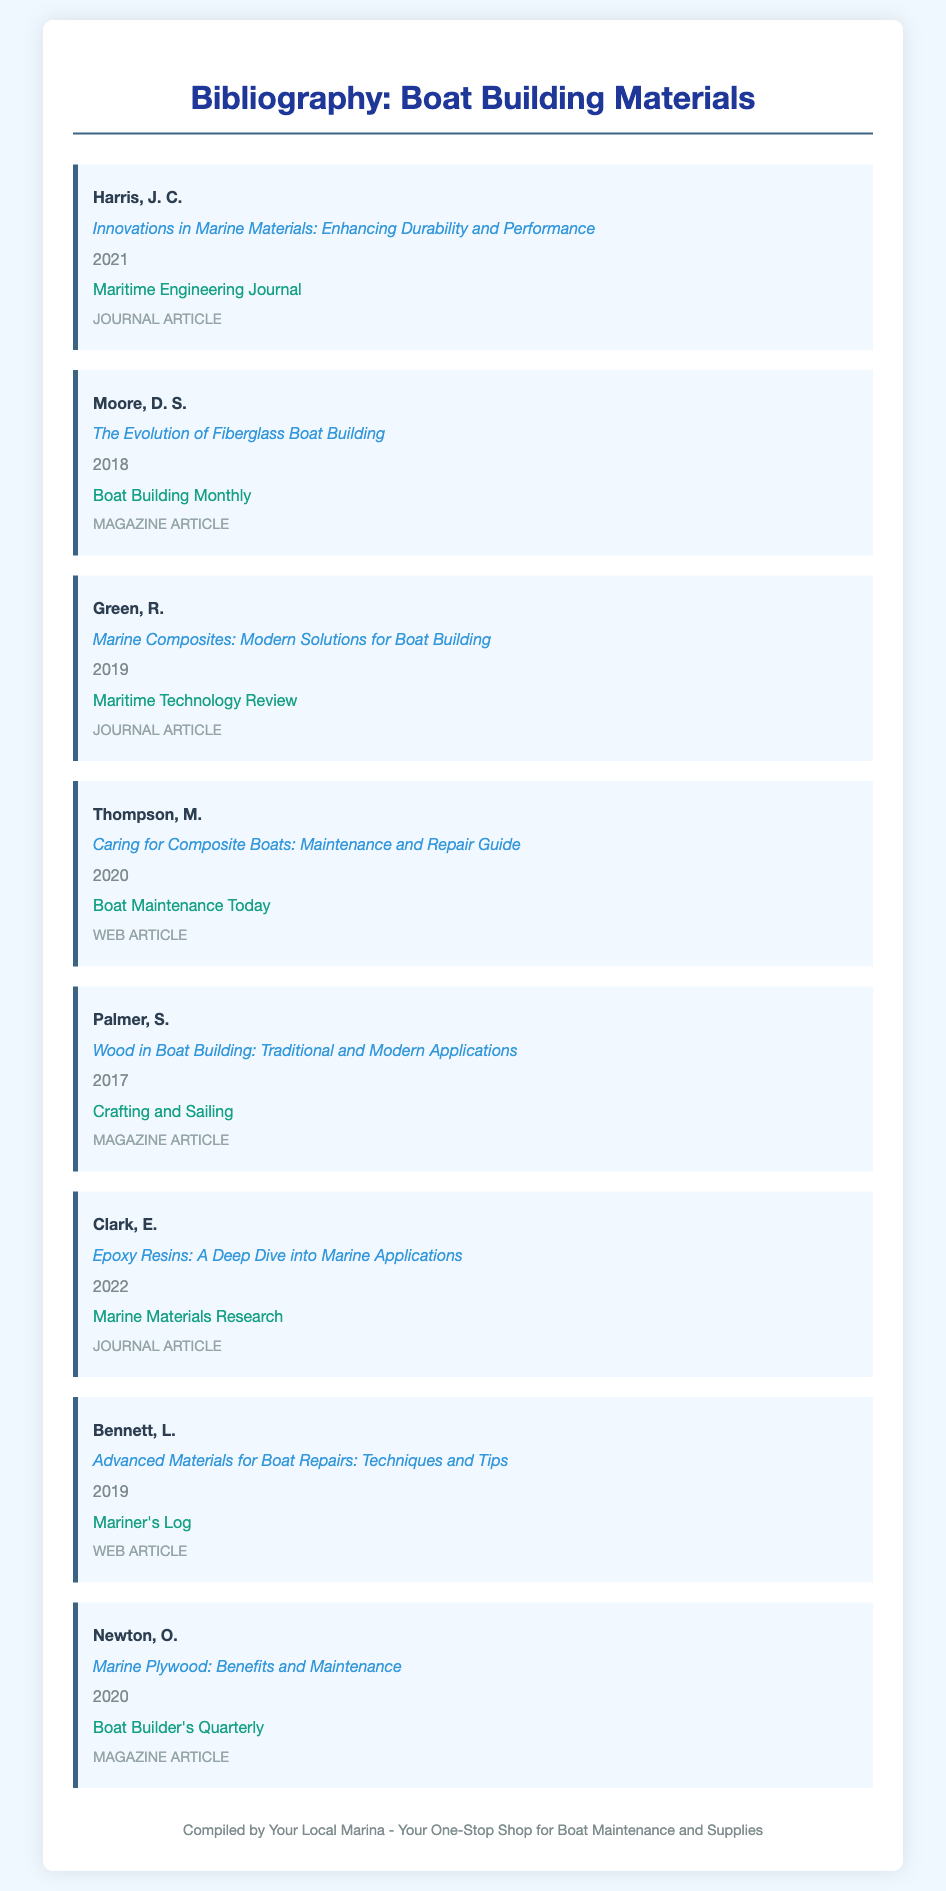What is the title of the article by Harris, J. C.? The title is found directly under the author's name in the document.
Answer: Innovations in Marine Materials: Enhancing Durability and Performance In what year was the article by Moore, D. S. published? The year of publication is listed below the article title.
Answer: 2018 Who published the article titled "Caring for Composite Boats: Maintenance and Repair Guide"? The publisher's name is stated in the bibliography item.
Answer: Boat Maintenance Today What is the focus of the article by Green, R.? The focus can be determined from the title of the article.
Answer: Marine Composites: Modern Solutions for Boat Building How many articles in the bibliography were published in 2020? The number is determined by counting the entries with the year 2020 under the year heading.
Answer: 3 What type of document is "Advanced Materials for Boat Repairs: Techniques and Tips"? The type is specified clearly in the document below the title.
Answer: Web Article Which author has multiple publications in this bibliography? The question asks for an author who appears more than once in the document.
Answer: None What is the most recent publication listed in the bibliography? The most recent publication can be found by checking the years listed for each item.
Answer: 2022 